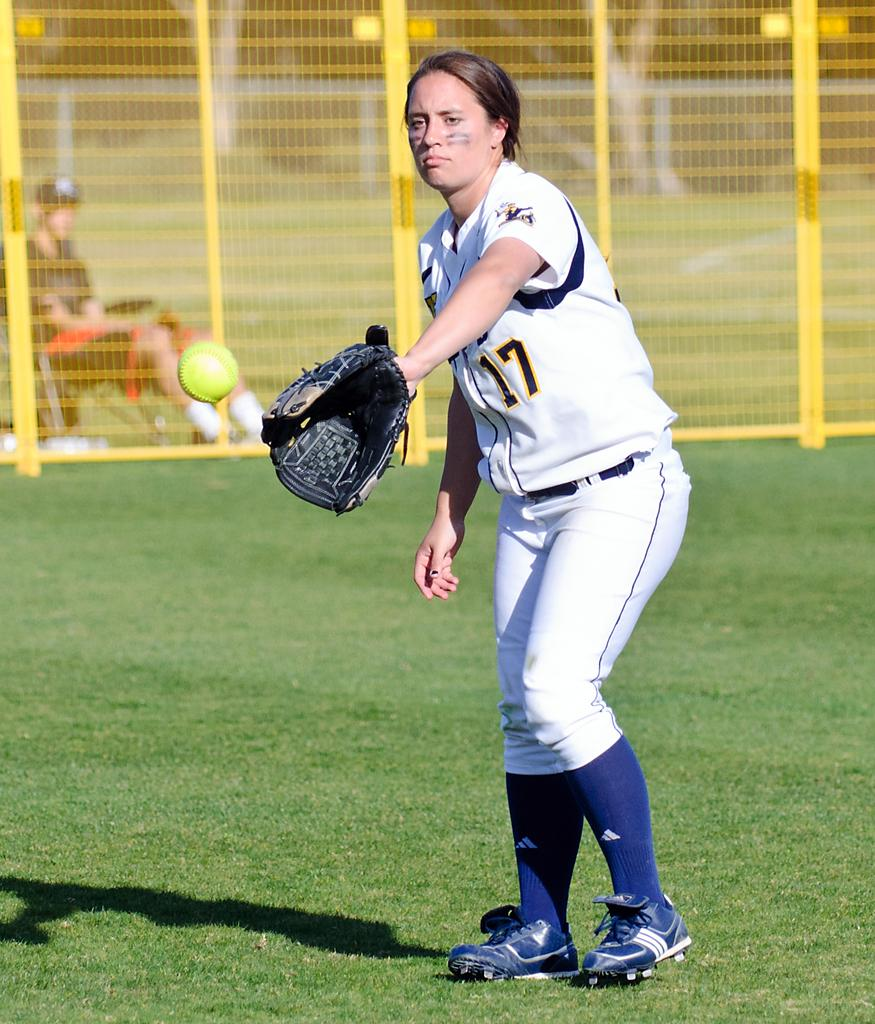<image>
Summarize the visual content of the image. The girl player wears the number 17 shirt. 